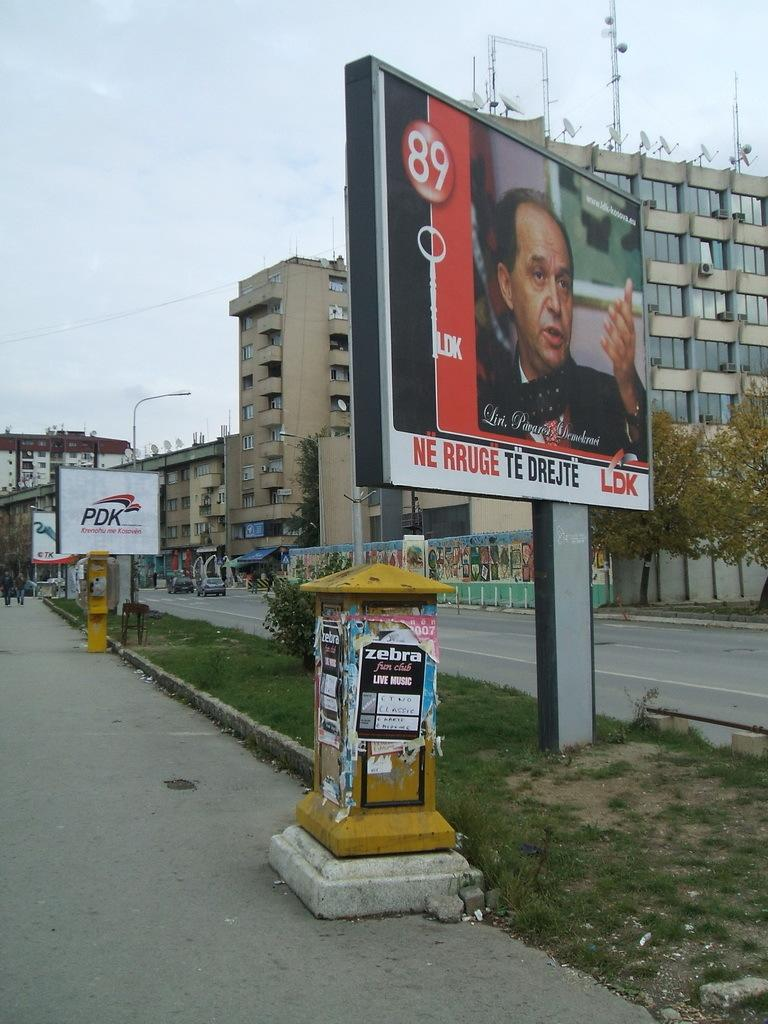<image>
Share a concise interpretation of the image provided. A billboard written in a foreign language stands above a yellow container with a sticker saying Zebra on the side. 